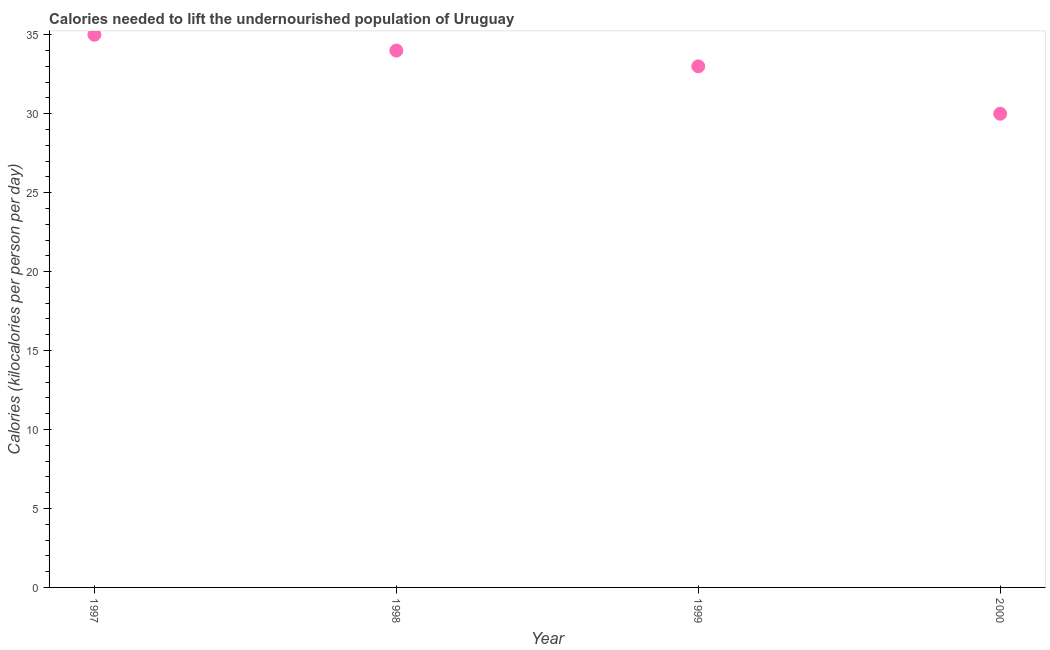What is the depth of food deficit in 1998?
Offer a very short reply. 34. Across all years, what is the maximum depth of food deficit?
Offer a very short reply. 35. Across all years, what is the minimum depth of food deficit?
Offer a terse response. 30. What is the sum of the depth of food deficit?
Make the answer very short. 132. What is the difference between the depth of food deficit in 1998 and 2000?
Offer a terse response. 4. What is the median depth of food deficit?
Offer a very short reply. 33.5. Do a majority of the years between 2000 and 1997 (inclusive) have depth of food deficit greater than 22 kilocalories?
Provide a succinct answer. Yes. What is the ratio of the depth of food deficit in 1997 to that in 1999?
Your answer should be very brief. 1.06. Is the difference between the depth of food deficit in 1997 and 2000 greater than the difference between any two years?
Your answer should be very brief. Yes. Is the sum of the depth of food deficit in 1997 and 2000 greater than the maximum depth of food deficit across all years?
Make the answer very short. Yes. What is the difference between the highest and the lowest depth of food deficit?
Make the answer very short. 5. How many dotlines are there?
Provide a short and direct response. 1. Does the graph contain grids?
Offer a very short reply. No. What is the title of the graph?
Provide a short and direct response. Calories needed to lift the undernourished population of Uruguay. What is the label or title of the Y-axis?
Your answer should be very brief. Calories (kilocalories per person per day). What is the Calories (kilocalories per person per day) in 1997?
Provide a short and direct response. 35. What is the Calories (kilocalories per person per day) in 1998?
Provide a succinct answer. 34. What is the Calories (kilocalories per person per day) in 1999?
Ensure brevity in your answer.  33. What is the difference between the Calories (kilocalories per person per day) in 1997 and 1998?
Offer a very short reply. 1. What is the difference between the Calories (kilocalories per person per day) in 1997 and 2000?
Give a very brief answer. 5. What is the difference between the Calories (kilocalories per person per day) in 1999 and 2000?
Make the answer very short. 3. What is the ratio of the Calories (kilocalories per person per day) in 1997 to that in 1998?
Offer a terse response. 1.03. What is the ratio of the Calories (kilocalories per person per day) in 1997 to that in 1999?
Offer a very short reply. 1.06. What is the ratio of the Calories (kilocalories per person per day) in 1997 to that in 2000?
Your response must be concise. 1.17. What is the ratio of the Calories (kilocalories per person per day) in 1998 to that in 1999?
Offer a terse response. 1.03. What is the ratio of the Calories (kilocalories per person per day) in 1998 to that in 2000?
Ensure brevity in your answer.  1.13. 